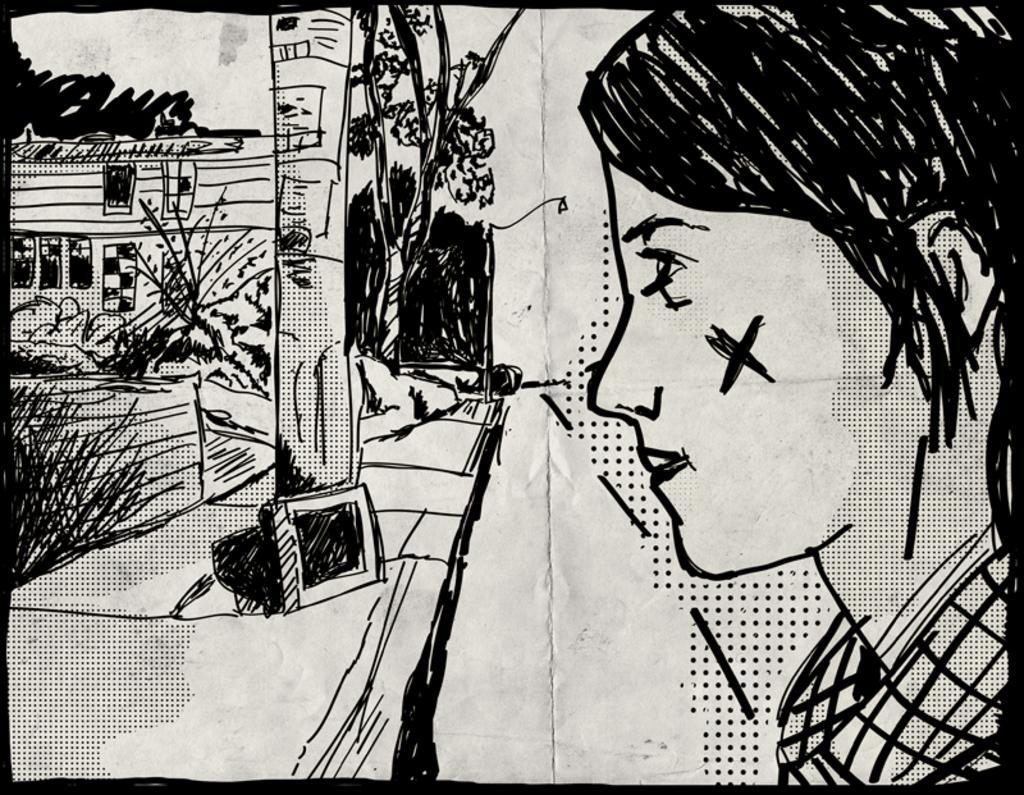Could you give a brief overview of what you see in this image? This is an edited picture. I can see a drawing of a person, plants, house and trees. 